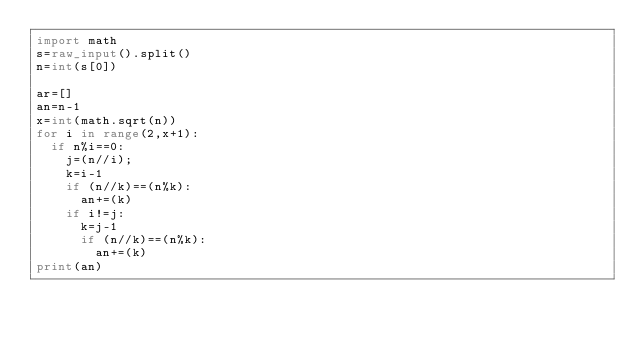<code> <loc_0><loc_0><loc_500><loc_500><_Python_>import math
s=raw_input().split()
n=int(s[0])

ar=[]
an=n-1
x=int(math.sqrt(n))
for i in range(2,x+1):
	if n%i==0:
		j=(n//i);
		k=i-1
		if (n//k)==(n%k):
			an+=(k)
		if i!=j:
			k=j-1
			if (n//k)==(n%k):
				an+=(k)
print(an)</code> 